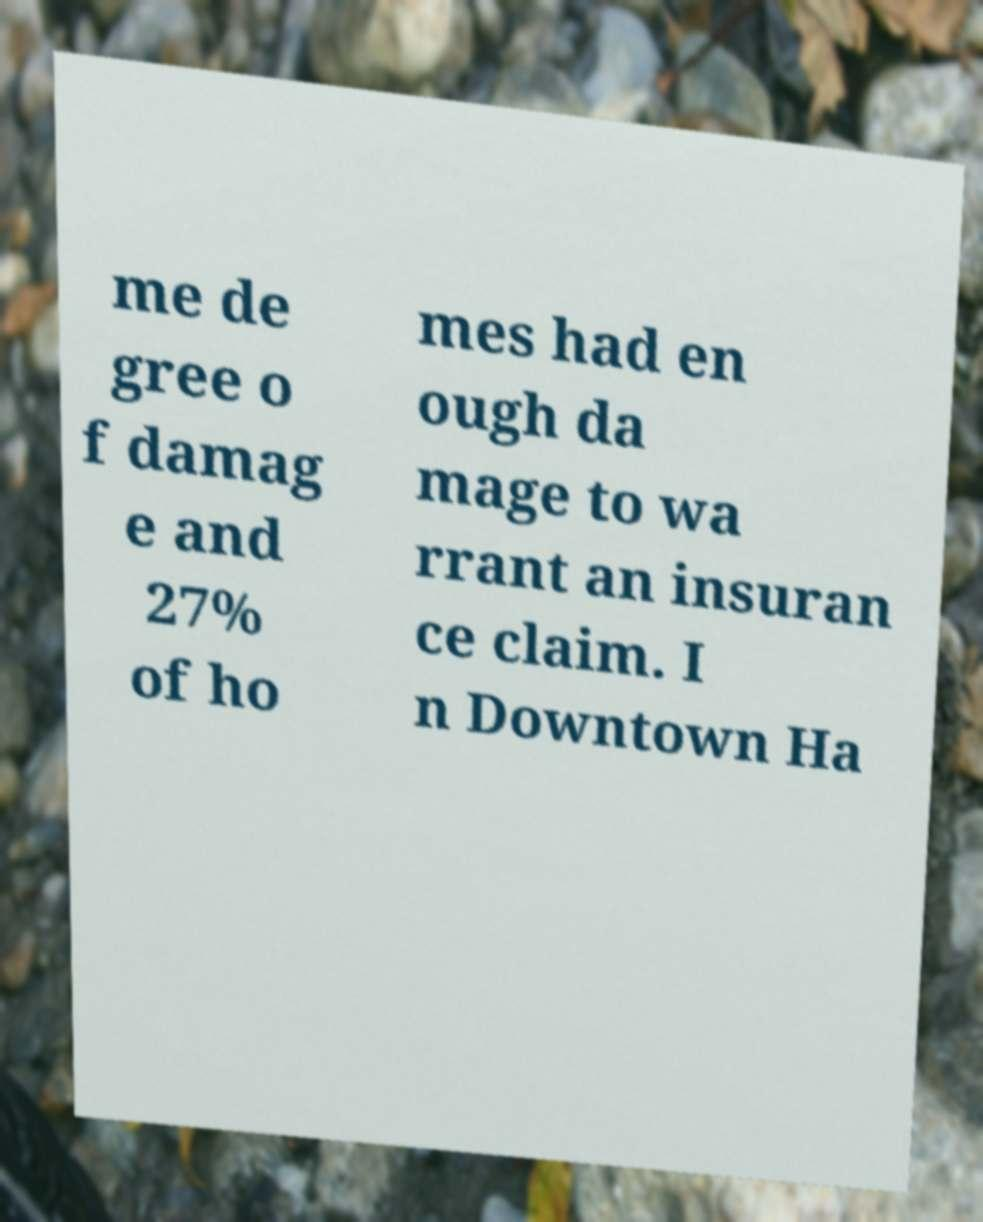What messages or text are displayed in this image? I need them in a readable, typed format. me de gree o f damag e and 27% of ho mes had en ough da mage to wa rrant an insuran ce claim. I n Downtown Ha 